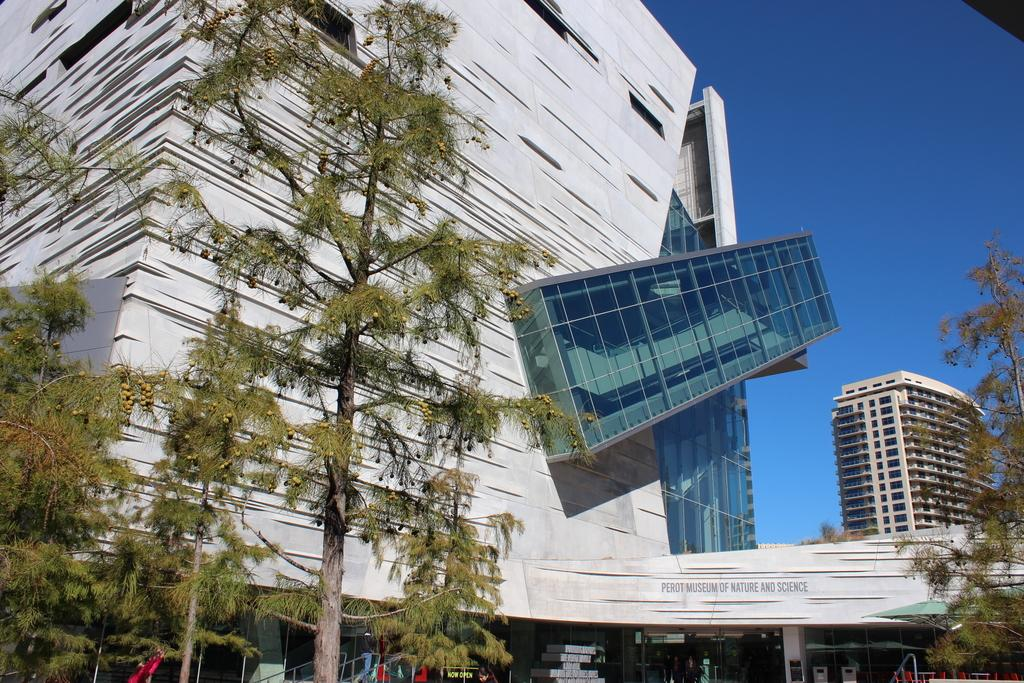What type of natural elements can be seen in the image? There are trees in the image. What type of man-made structures are present in the image? There are buildings in the image. What part of the sky is visible in the image? The sky is visible in the top right of the image. What type of fork can be seen in the image? There is no fork present in the image. What committee is responsible for the maintenance of the trees in the image? There is no information about a committee responsible for the maintenance of the trees in the image. 